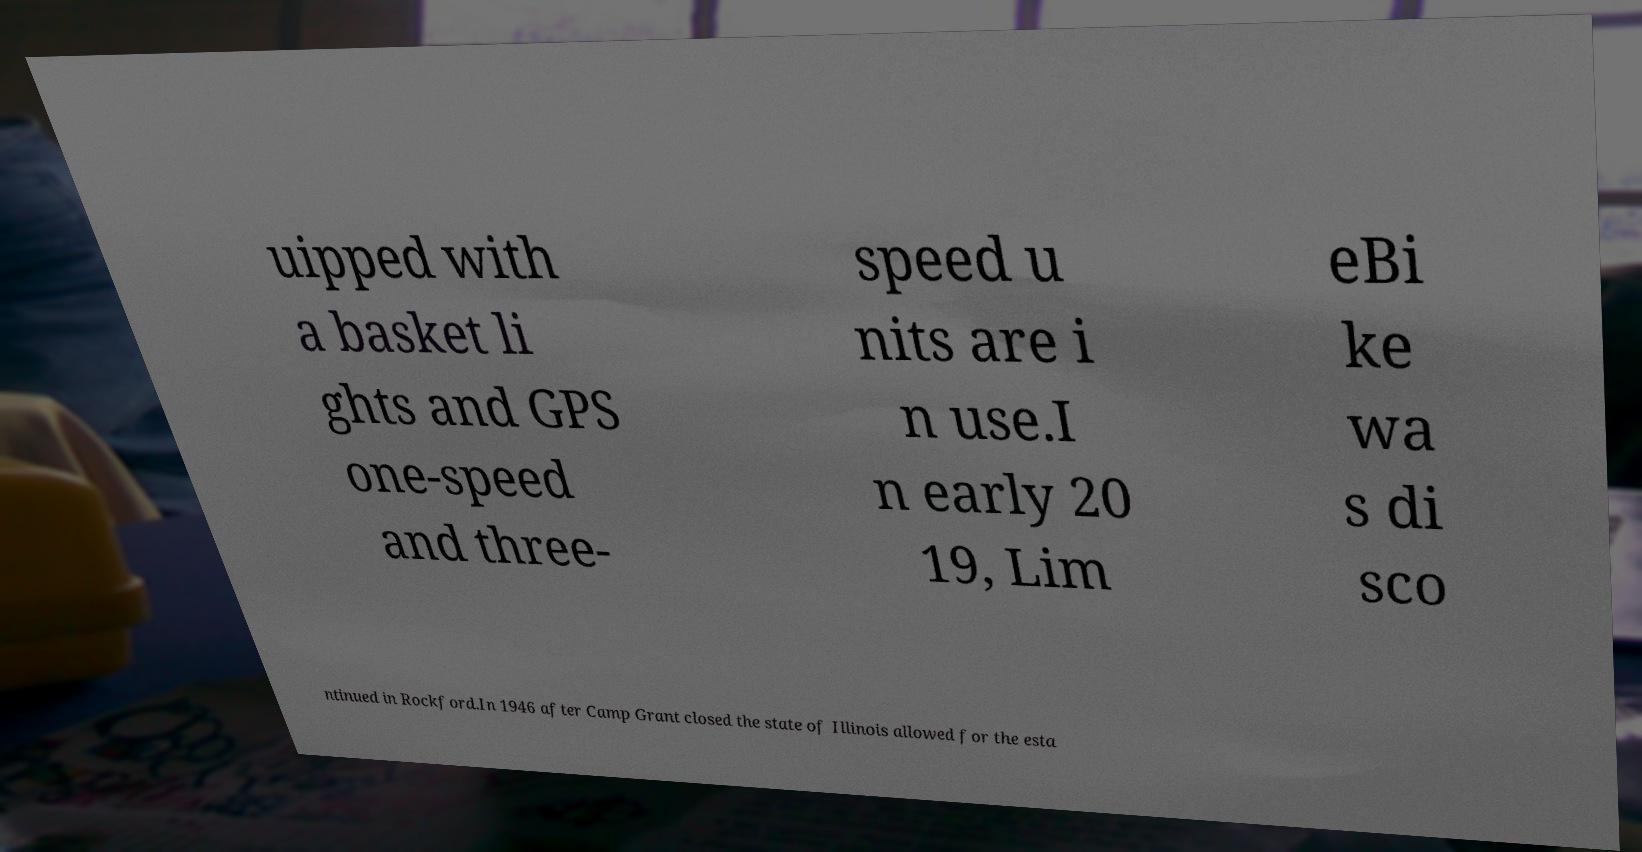Can you accurately transcribe the text from the provided image for me? uipped with a basket li ghts and GPS one-speed and three- speed u nits are i n use.I n early 20 19, Lim eBi ke wa s di sco ntinued in Rockford.In 1946 after Camp Grant closed the state of Illinois allowed for the esta 